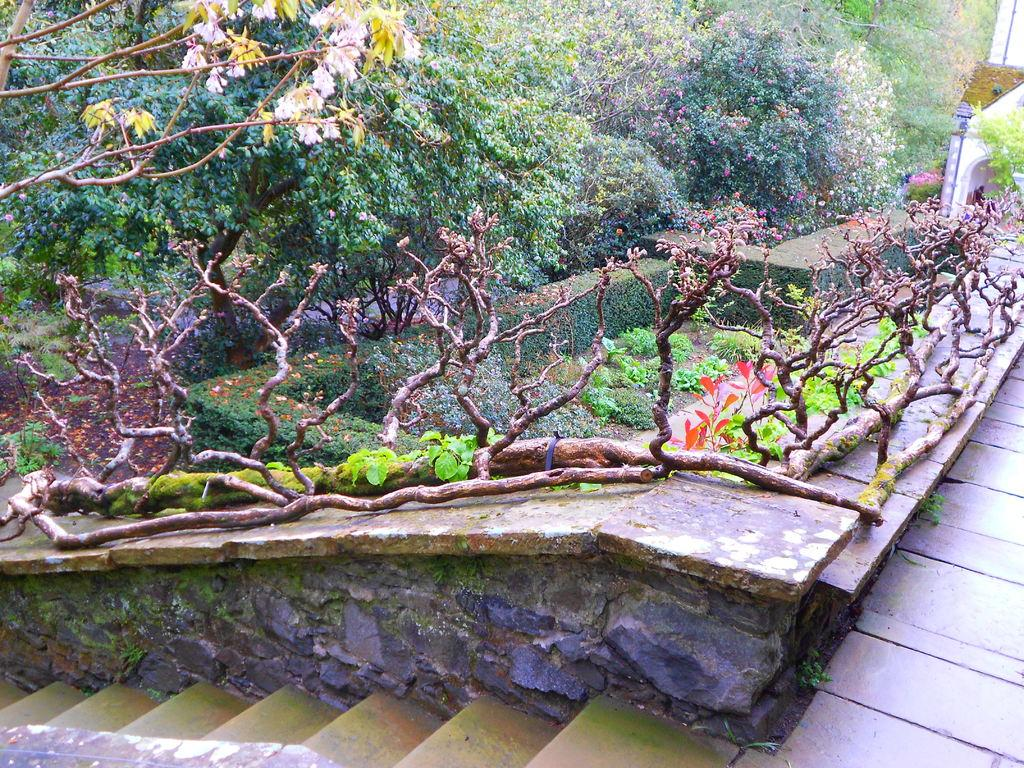What type of vegetation can be seen in the image? There are trees, plants, and grass visible in the image. Can you describe the natural environment depicted in the image? The image features trees, plants, and grass, which suggests a natural, outdoor setting. How many chickens can be seen in the image? There are no chickens present in the image; it features trees, plants, and grass. What type of ray is visible in the image? There is no ray present in the image; it features trees, plants, and grass. 